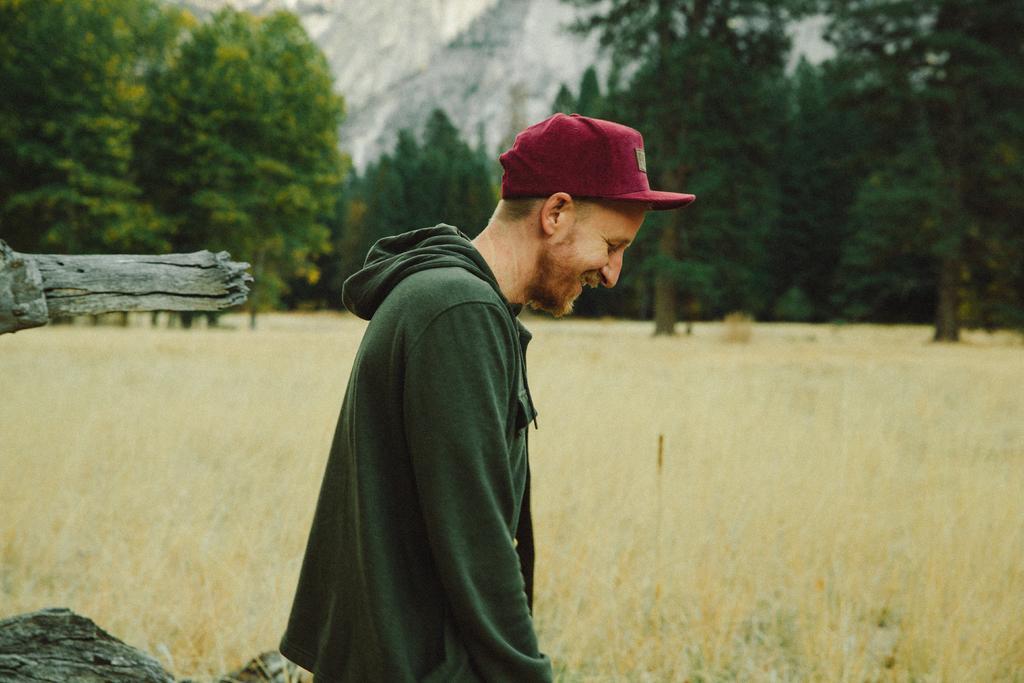Describe this image in one or two sentences. In the image we can see a man in the middle of the image. The man is wearing clothes, cap and he is smiling. Here we can see the grass, wooden log, trees and the background is slightly blurred. 